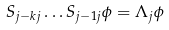<formula> <loc_0><loc_0><loc_500><loc_500>S _ { j - k j } \dots S _ { j - 1 j } \phi = \Lambda _ { j } \phi</formula> 